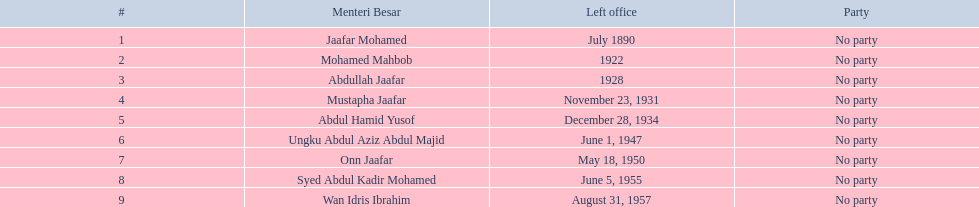Who are all of the menteri besars? Jaafar Mohamed, Mohamed Mahbob, Abdullah Jaafar, Mustapha Jaafar, Abdul Hamid Yusof, Ungku Abdul Aziz Abdul Majid, Onn Jaafar, Syed Abdul Kadir Mohamed, Wan Idris Ibrahim. When did each take office? 1886, June 1920, September 1923, September 16, 1928, November 23, 1931, April 1935, June 1, 1947, February 18, 1952, October 1, 1955. When did they leave? July 1890, 1922, 1928, November 23, 1931, December 28, 1934, June 1, 1947, May 18, 1950, June 5, 1955, August 31, 1957. And which spent the most time in office? Ungku Abdul Aziz Abdul Majid. What are all the people that were menteri besar of johor? Jaafar Mohamed, Mohamed Mahbob, Abdullah Jaafar, Mustapha Jaafar, Abdul Hamid Yusof, Ungku Abdul Aziz Abdul Majid, Onn Jaafar, Syed Abdul Kadir Mohamed, Wan Idris Ibrahim. Who ruled the longest? Ungku Abdul Aziz Abdul Majid. Who were all of the menteri besars? Jaafar Mohamed, Mohamed Mahbob, Abdullah Jaafar, Mustapha Jaafar, Abdul Hamid Yusof, Ungku Abdul Aziz Abdul Majid, Onn Jaafar, Syed Abdul Kadir Mohamed, Wan Idris Ibrahim. When did they take office? 1886, June 1920, September 1923, September 16, 1928, November 23, 1931, April 1935, June 1, 1947, February 18, 1952, October 1, 1955. And when did they leave? July 1890, 1922, 1928, November 23, 1931, December 28, 1934, June 1, 1947, May 18, 1950, June 5, 1955, August 31, 1957. Now, who was in office for less than four years? Mohamed Mahbob. 